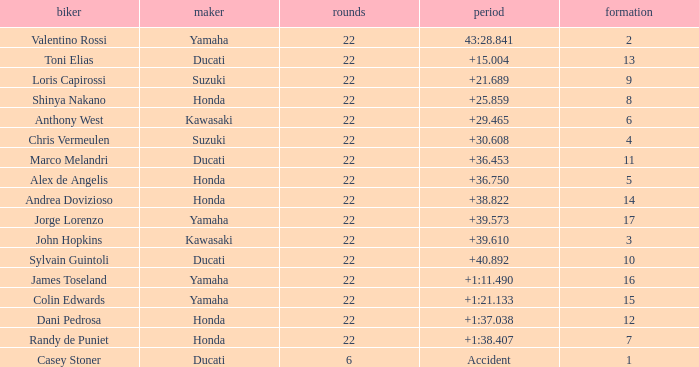What laps did Honda do with a time of +1:38.407? 22.0. 